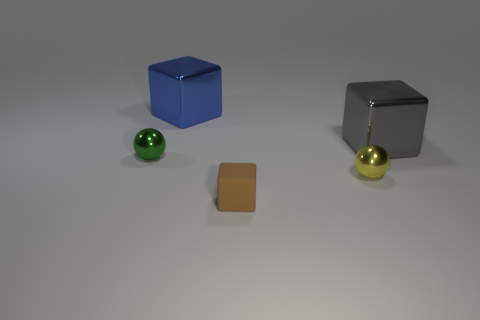There is a sphere that is to the left of the small metallic thing in front of the small shiny ball that is on the left side of the large blue block; how big is it? The sphere to the left of the small metallic object, which in turn is in front of another small shiny sphere, appears to be relatively small in size, slightly larger than the brown square object in the foreground but smaller than the nearby large blue block. 